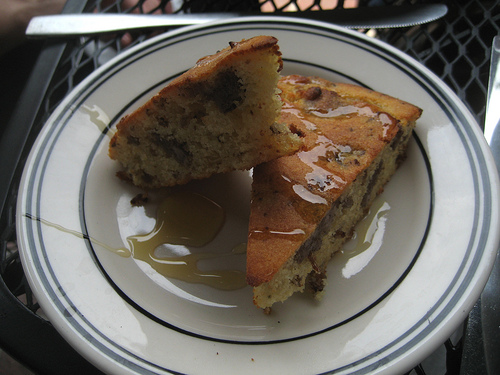<image>
Is there a food to the left of the plate? No. The food is not to the left of the plate. From this viewpoint, they have a different horizontal relationship. 